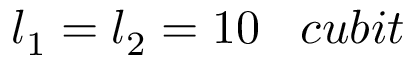Convert formula to latex. <formula><loc_0><loc_0><loc_500><loc_500>l _ { 1 } = l _ { 2 } = 1 0 \, c u b i t</formula> 